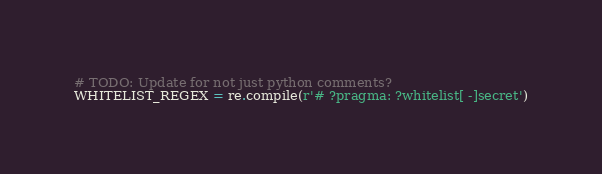Convert code to text. <code><loc_0><loc_0><loc_500><loc_500><_Python_># TODO: Update for not just python comments?
WHITELIST_REGEX = re.compile(r'# ?pragma: ?whitelist[ -]secret')
</code> 